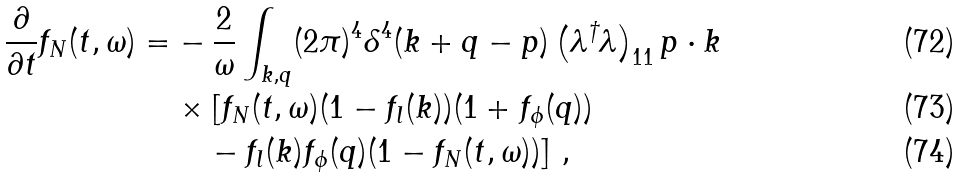<formula> <loc_0><loc_0><loc_500><loc_500>\frac { \partial } { \partial t } f _ { N } ( t , \omega ) = & - \frac { 2 } { \omega } \int _ { k , q } ( 2 \pi ) ^ { 4 } \delta ^ { 4 } ( k + q - p ) \left ( \lambda ^ { \dagger } \lambda \right ) _ { 1 1 } p \cdot k \\ & \times [ f _ { N } ( t , \omega ) ( 1 - f _ { l } ( k ) ) ( 1 + f _ { \phi } ( q ) ) \\ & \quad - f _ { l } ( k ) f _ { \phi } ( q ) ( 1 - f _ { N } ( t , \omega ) ) ] \ ,</formula> 